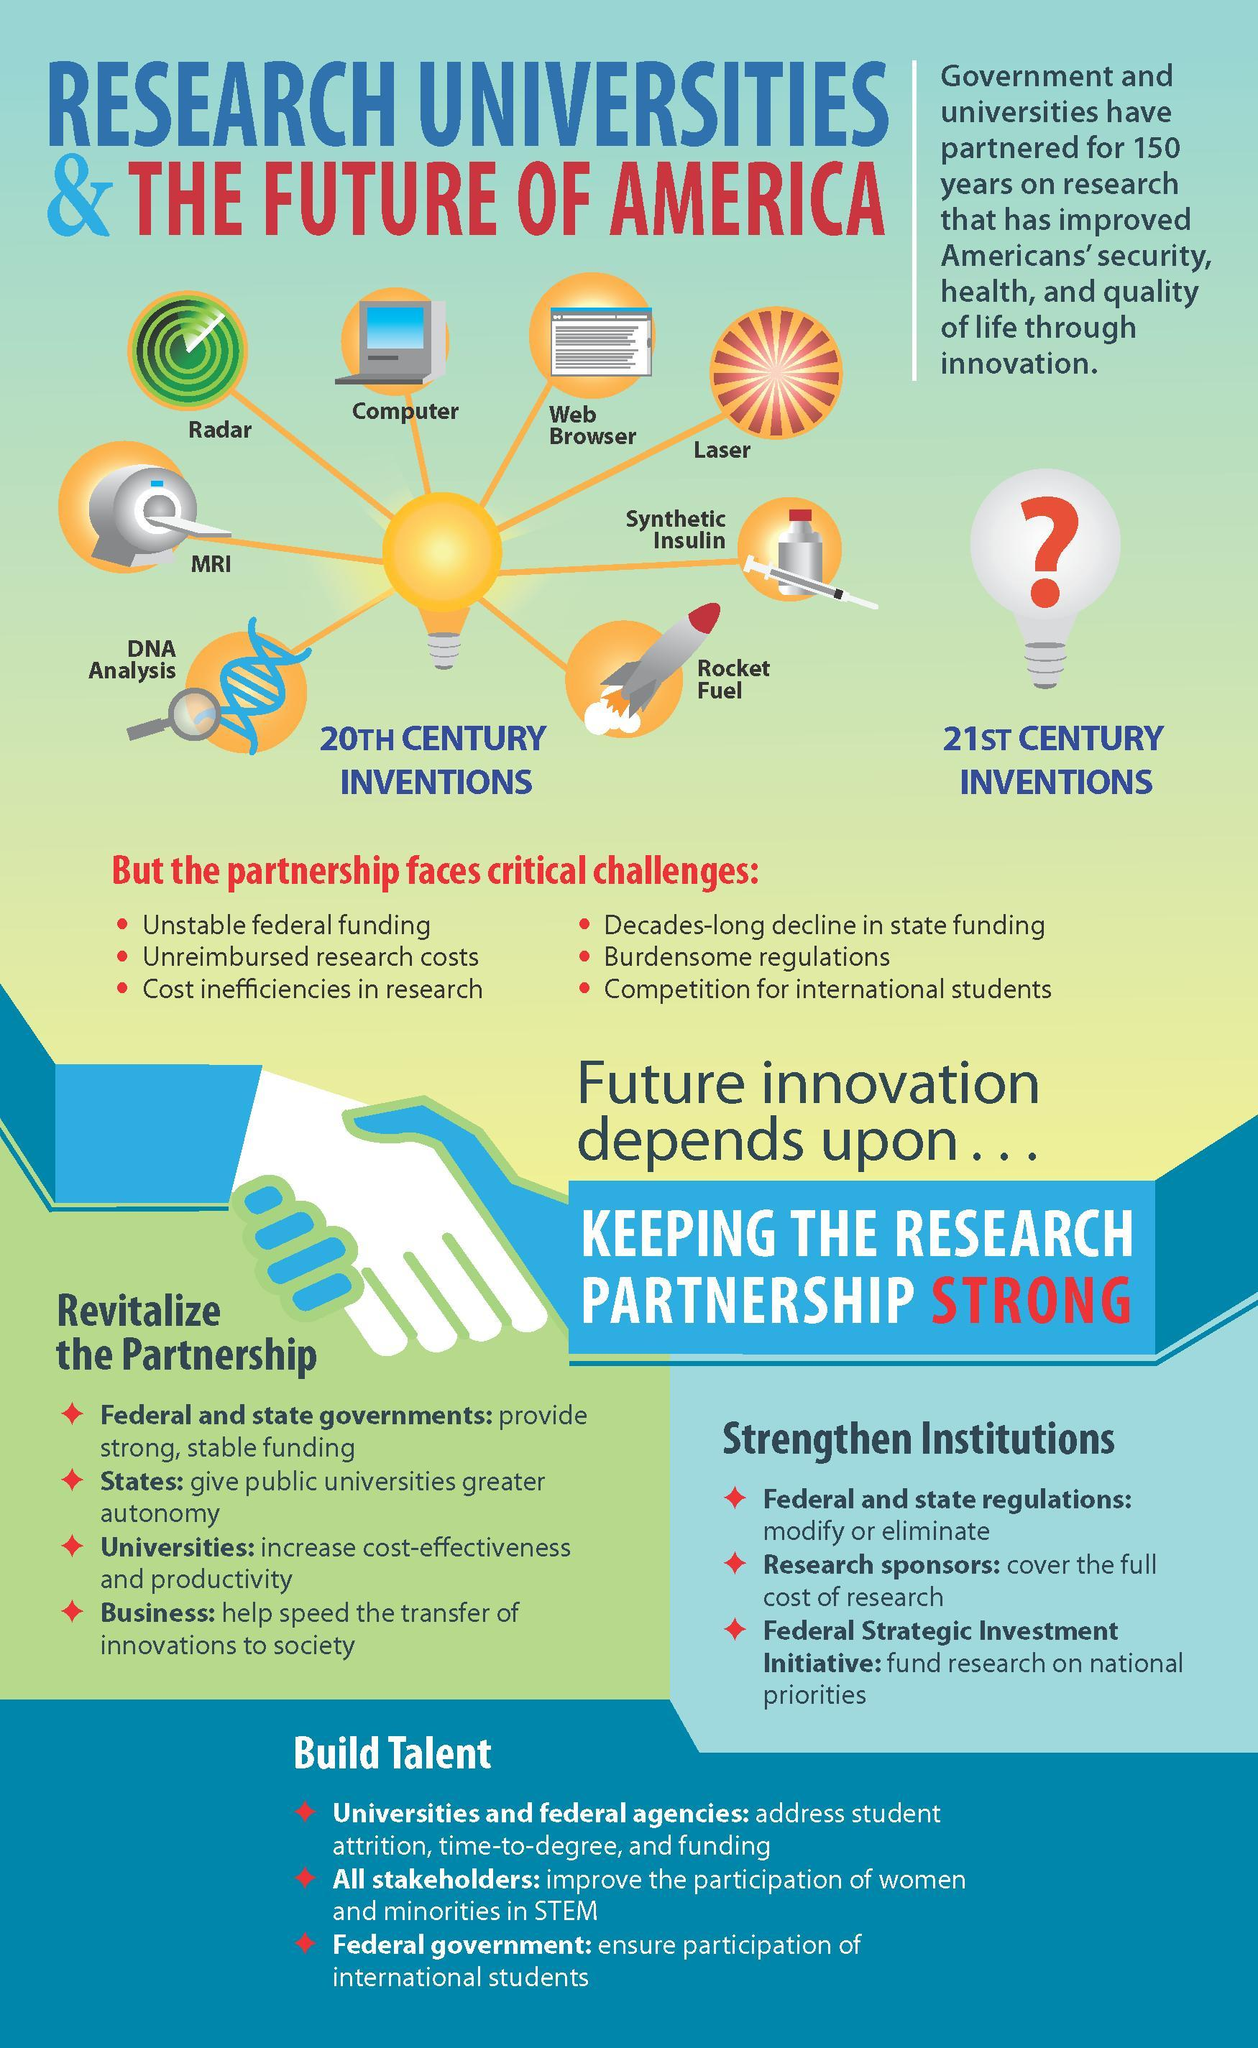How many inventions were made in the 20th century?
Answer the question with a short phrase. 8 